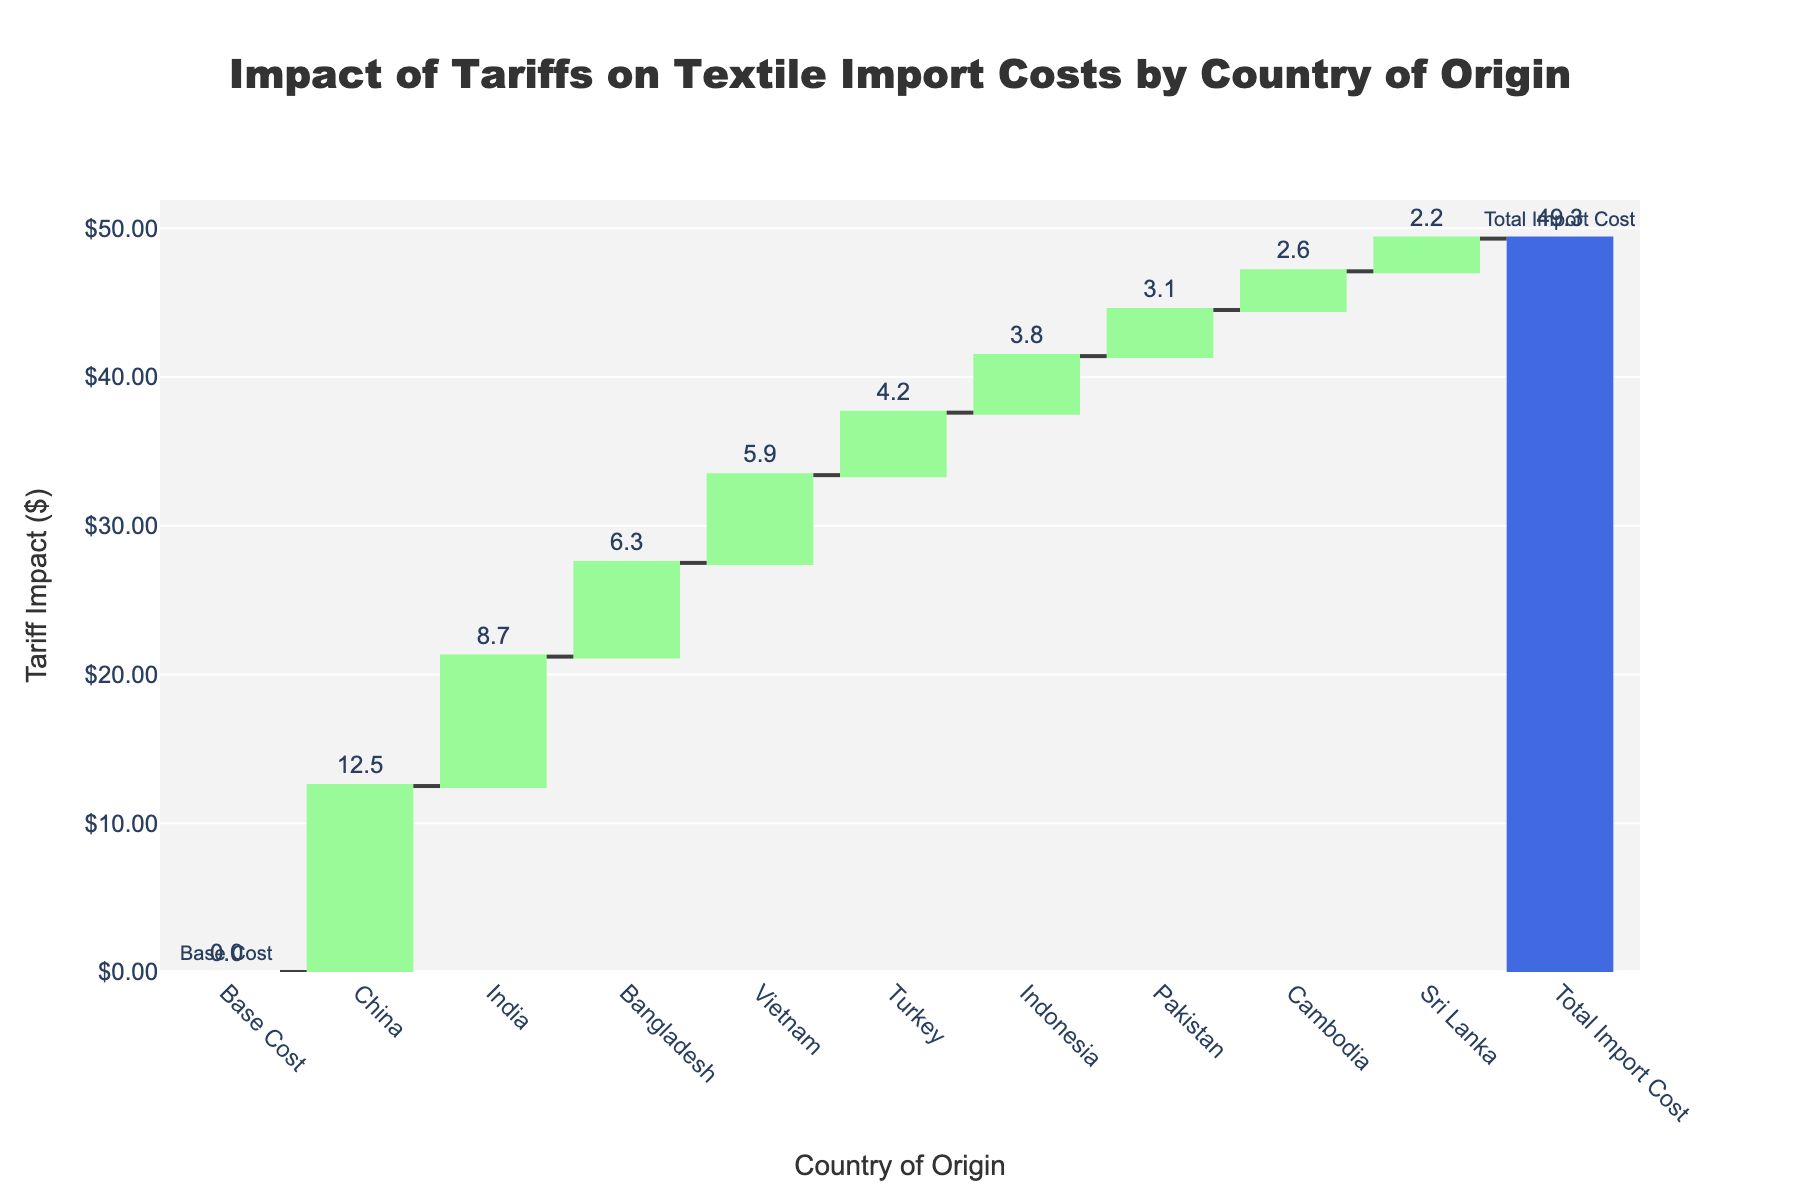What's the title of the chart? The title is usually located at the top of the chart. In this figure, the title reads "Impact of Tariffs on Textile Import Costs by Country of Origin," indicating what the figure represents.
Answer: "Impact of Tariffs on Textile Import Costs by Country of Origin" Which country has the highest tariff impact on textile imports? By examining the height of the bars in the Waterfall Chart, you can see that China has the highest tariff impact among the listed countries because it has the tallest bar.
Answer: China How much is the total tariff impact on textile import costs? Look at the final total bar on the right side of the Waterfall Chart labeled "Total Import Cost." The height of this bar represents the cumulative impact of tariffs from all countries listed.
Answer: 49.3 What is the tariff impact for Vietnam? Find the bar labeled "Vietnam" and read the value displayed on the bar.
Answer: 5.9 How does the tariff impact of India compare to that of Turkey? Compare the heights of the bars for India and Turkey. The bar for India is taller than the one for Turkey, indicating India has a higher tariff impact.
Answer: India has a higher tariff impact than Turkey Calculate the sum of the tariff impacts from Bangladesh, Vietnam, and Indonesia. Add up the values from the bars labeled "Bangladesh" (6.3), "Vietnam" (5.9), and "Indonesia" (3.8). The total sum is 6.3 + 5.9 + 3.8 = 16.0.
Answer: 16.0 How many countries are included in the chart apart from the "Base Cost" and "Total Import Cost"? Count the number of bars between "Base Cost" and "Total Import Cost" to find the number of countries represented. There are 9 countries listed.
Answer: 9 Which country has the smallest tariff impact among the listed ones? Identify the shortest bar in the chart, which corresponds to Sri Lanka, having the smallest tariff impact value of 2.2.
Answer: Sri Lanka What percentage of the total import cost is due to China's tariff impact? Divide China's tariff impact (12.5) by the total import cost (49.3) and multiply by 100. (12.5 / 49.3) * 100 ≈ 25.35%
Answer: Approximately 25.35% What’s the average tariff impact per country, excluding the "Base Cost" and "Total Import Cost"? Sum all the tariff impact values from each country and divide by the number of countries. The total sum is 12.5 + 8.7 + 6.3 + 5.9 + 4.2 + 3.8 + 3.1 + 2.6 + 2.2 = 49.3. Given there are 9 countries, the average tariff impact is 49.3 / 9 ≈ 5.48.
Answer: Approximately 5.48 